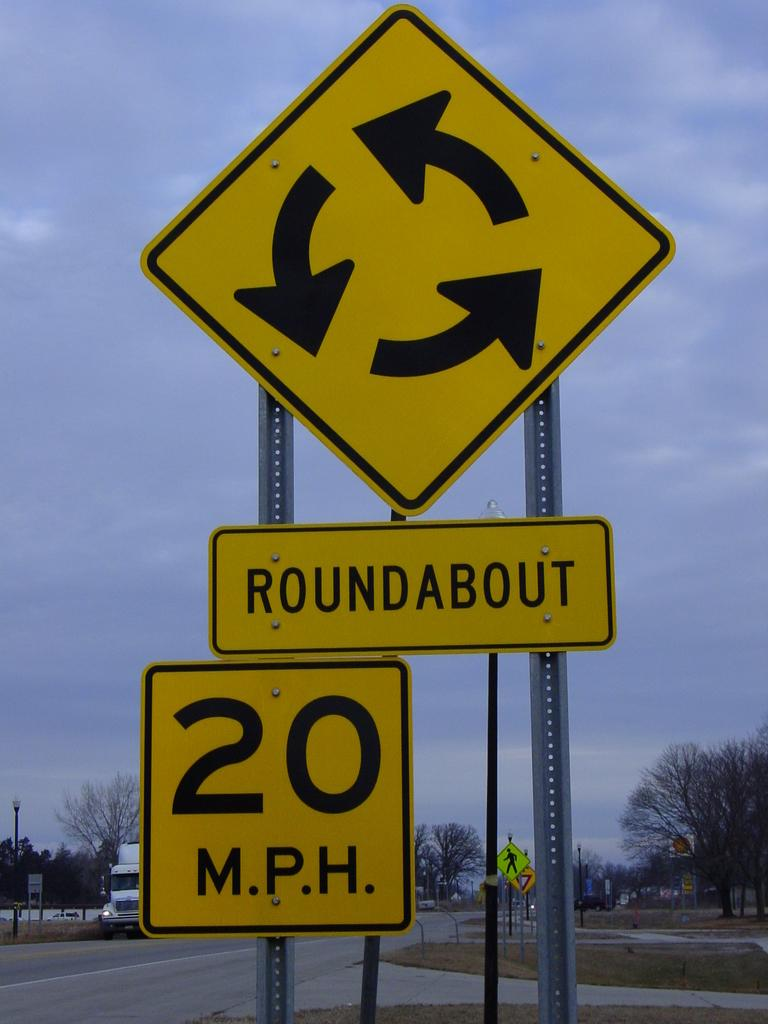Provide a one-sentence caption for the provided image. A yellow and black sign that says Roundabout and 20mph. 